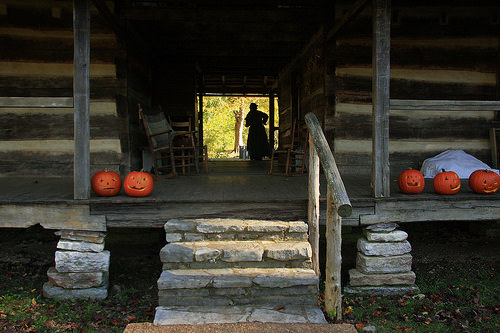<image>
Is there a pumpkin on the house? No. The pumpkin is not positioned on the house. They may be near each other, but the pumpkin is not supported by or resting on top of the house. 